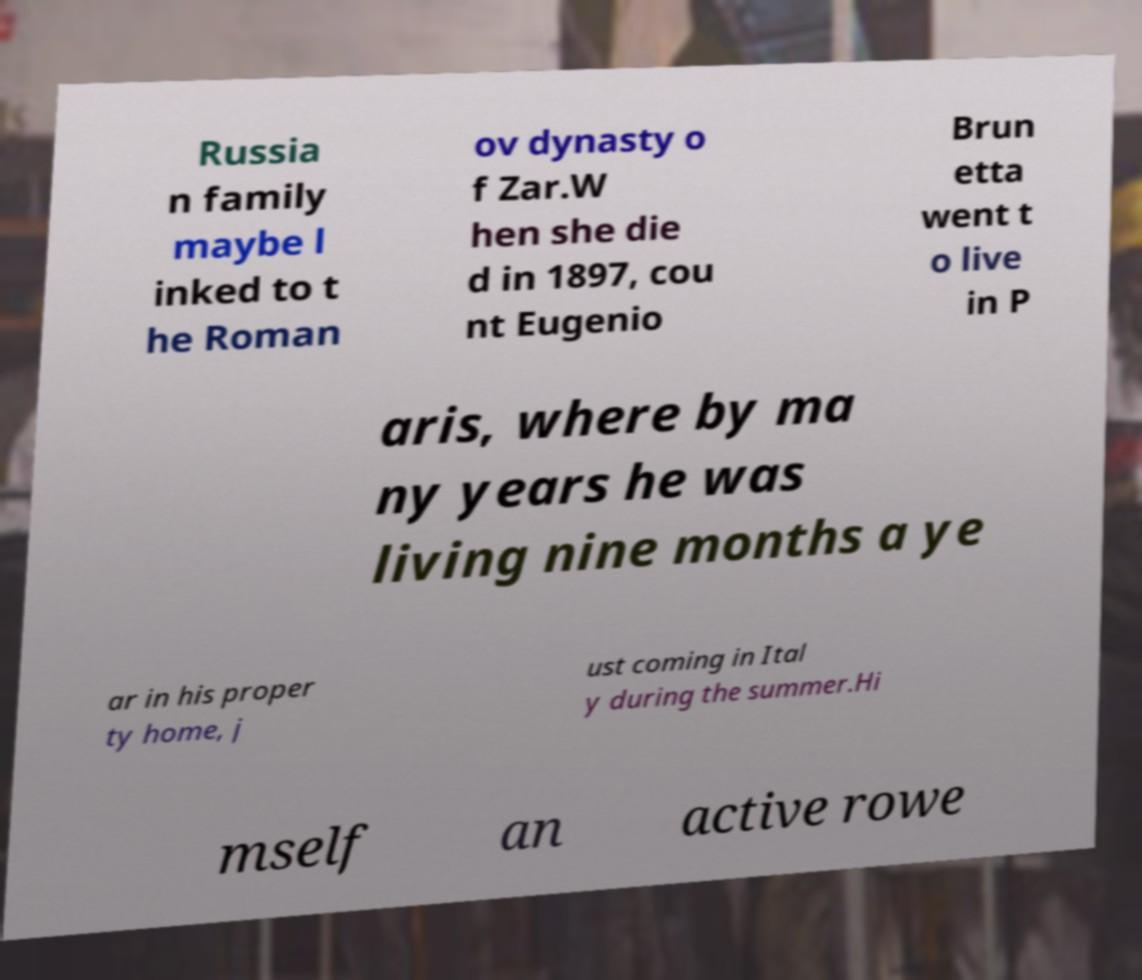Please read and relay the text visible in this image. What does it say? Russia n family maybe l inked to t he Roman ov dynasty o f Zar.W hen she die d in 1897, cou nt Eugenio Brun etta went t o live in P aris, where by ma ny years he was living nine months a ye ar in his proper ty home, j ust coming in Ital y during the summer.Hi mself an active rowe 